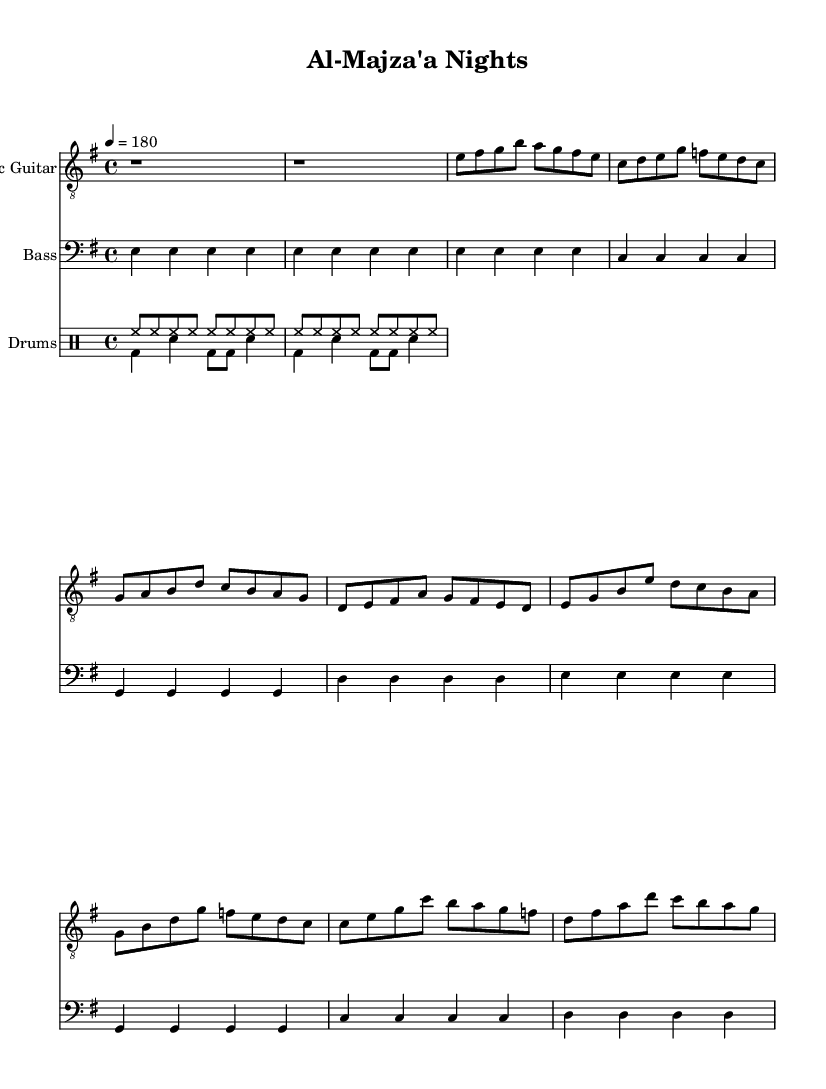What is the key signature of this music? The key signature is indicated at the beginning of the score, showing the sharp or flat notes that are used throughout the piece. In this case, the key signature shows one sharp, which corresponds to E minor.
Answer: E minor What is the time signature of this music? The time signature is found at the beginning of the score, which tells us how many beats are in each measure and what note value is considered one beat. Here, the time signature is 4/4, meaning there are four beats in each measure with a quarter note getting one beat.
Answer: 4/4 What is the tempo marking of this music? The tempo marking is specified in beats per minute and is crucial for performing the piece at the intended speed. In this score, the tempo is indicated as 4 = 180, meaning there are 180 beats per minute.
Answer: 180 How many measures are in the chorus section of this score? To find the number of measures in the chorus, we need to locate the section labeled "Chorus" and count the number of measure bars. There are four measures in the chorus section.
Answer: 4 What are the notable features of the lyrics? By examining the lyrics written below the notation, we can identify themes and keywords related to the daily life in Al-Majza'a, such as 'traditions', 'rural life', and 'Palestinian roots', which reflect the cultural significance of the song.
Answer: Traditions, rural life, Palestinian roots What instruments are included in this arrangement? The arrangement specifies various staves for the different instruments used, which in this case includes Electric Guitar, Bass, and Drums. Each instrument has its own designated staff and notation.
Answer: Electric Guitar, Bass, Drums What characterizes the punk style of this anthem? The punk style in this anthem is characterized by its fast tempo, straightforward lyrical themes focusing on everyday life and customs, and a raw musical energy that reflects the cultural narrative of the rural communities.
Answer: Fast tempo, straightforward themes, raw energy 